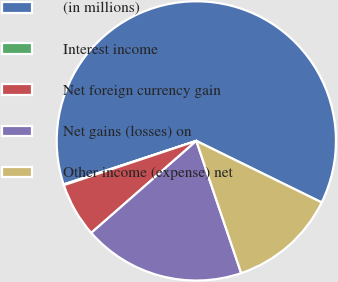Convert chart. <chart><loc_0><loc_0><loc_500><loc_500><pie_chart><fcel>(in millions)<fcel>Interest income<fcel>Net foreign currency gain<fcel>Net gains (losses) on<fcel>Other income (expense) net<nl><fcel>62.3%<fcel>0.09%<fcel>6.31%<fcel>18.76%<fcel>12.53%<nl></chart> 